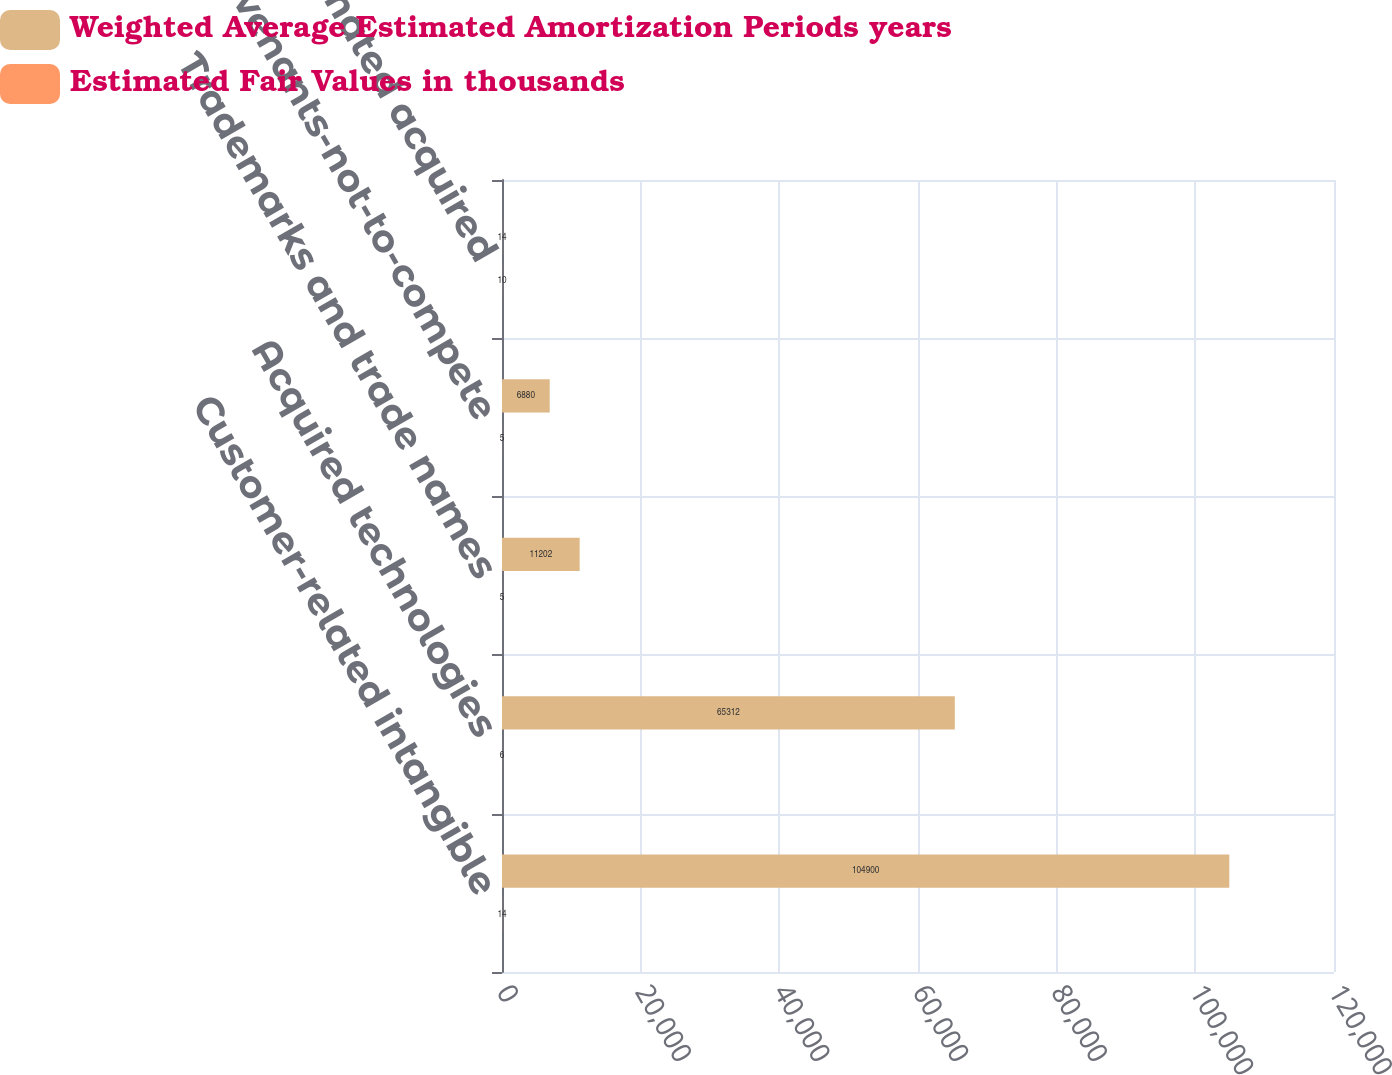Convert chart. <chart><loc_0><loc_0><loc_500><loc_500><stacked_bar_chart><ecel><fcel>Customer-related intangible<fcel>Acquired technologies<fcel>Trademarks and trade names<fcel>Covenants-not-to-compete<fcel>Total estimated acquired<nl><fcel>Weighted Average Estimated Amortization Periods years<fcel>104900<fcel>65312<fcel>11202<fcel>6880<fcel>14<nl><fcel>Estimated Fair Values in thousands<fcel>14<fcel>6<fcel>5<fcel>5<fcel>10<nl></chart> 